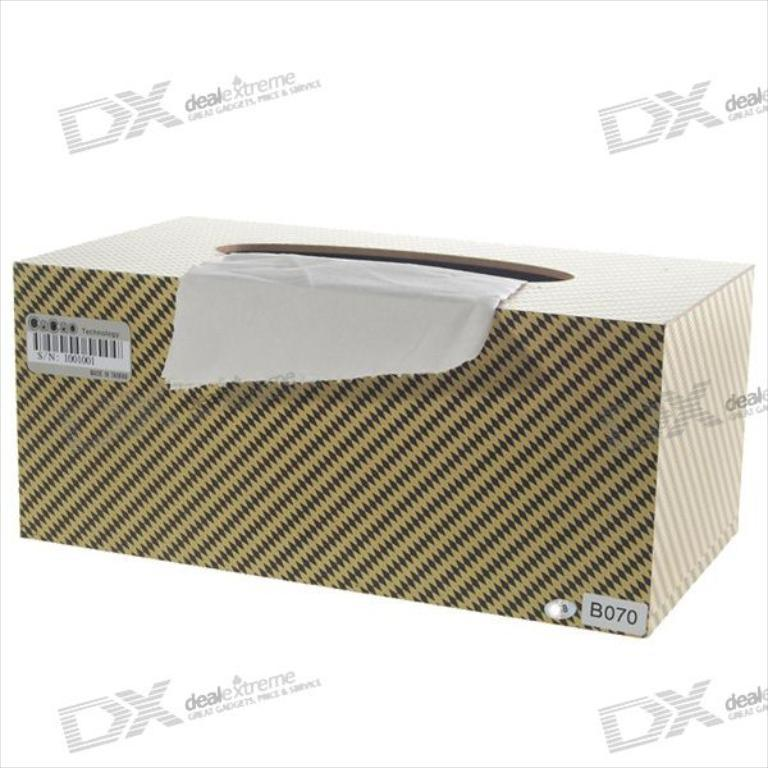<image>
Present a compact description of the photo's key features. A box of tissues surrounded by watermarks for DX: Deal Extreme. 